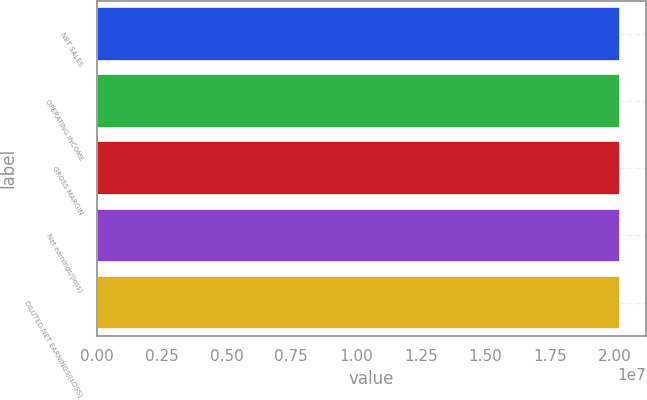<chart> <loc_0><loc_0><loc_500><loc_500><bar_chart><fcel>NET SALES<fcel>OPERATING INCOME<fcel>GROSS MARGIN<fcel>Net earnings/(loss)<fcel>DILUTED NET EARNINGS/(LOSS)<nl><fcel>2.0182e+07<fcel>2.0182e+07<fcel>2.0182e+07<fcel>2.0182e+07<fcel>2.0182e+07<nl></chart> 